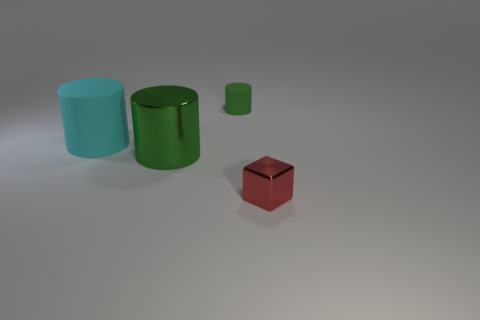What number of other things are the same color as the big metallic object?
Keep it short and to the point. 1. There is a metal thing that is on the left side of the small red block; does it have the same shape as the object that is behind the cyan matte cylinder?
Ensure brevity in your answer.  Yes. How many blocks are either tiny things or red things?
Make the answer very short. 1. Is the number of small red metallic blocks that are to the left of the cyan cylinder less than the number of small red objects?
Keep it short and to the point. Yes. Is the size of the red metal block the same as the green matte cylinder?
Keep it short and to the point. Yes. What number of things are metal objects that are behind the tiny red metal cube or small cyan rubber cylinders?
Provide a short and direct response. 1. There is a small thing that is in front of the big metallic cylinder to the right of the cyan cylinder; what is it made of?
Provide a succinct answer. Metal. Are there any cyan objects that have the same shape as the big green thing?
Your response must be concise. Yes. Does the red object have the same size as the matte cylinder behind the cyan rubber object?
Keep it short and to the point. Yes. How many objects are either small objects to the left of the small red metal block or cylinders in front of the green rubber thing?
Your answer should be very brief. 3. 